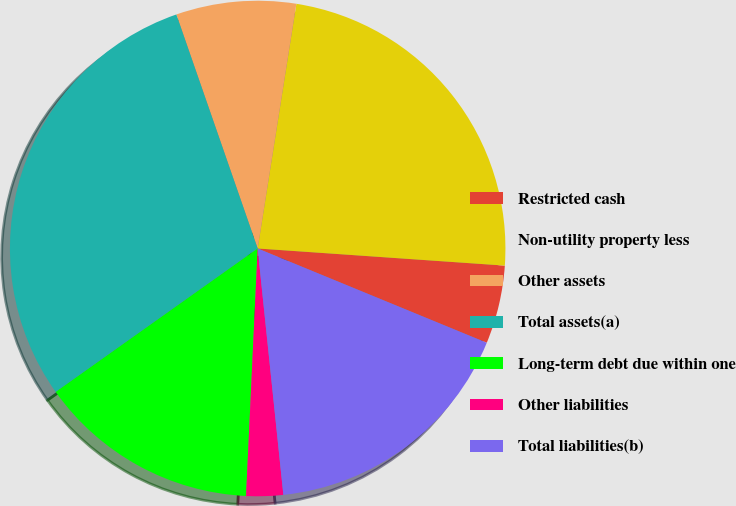Convert chart to OTSL. <chart><loc_0><loc_0><loc_500><loc_500><pie_chart><fcel>Restricted cash<fcel>Non-utility property less<fcel>Other assets<fcel>Total assets(a)<fcel>Long-term debt due within one<fcel>Other liabilities<fcel>Total liabilities(b)<nl><fcel>5.11%<fcel>23.6%<fcel>7.82%<fcel>29.5%<fcel>14.42%<fcel>2.4%<fcel>17.13%<nl></chart> 